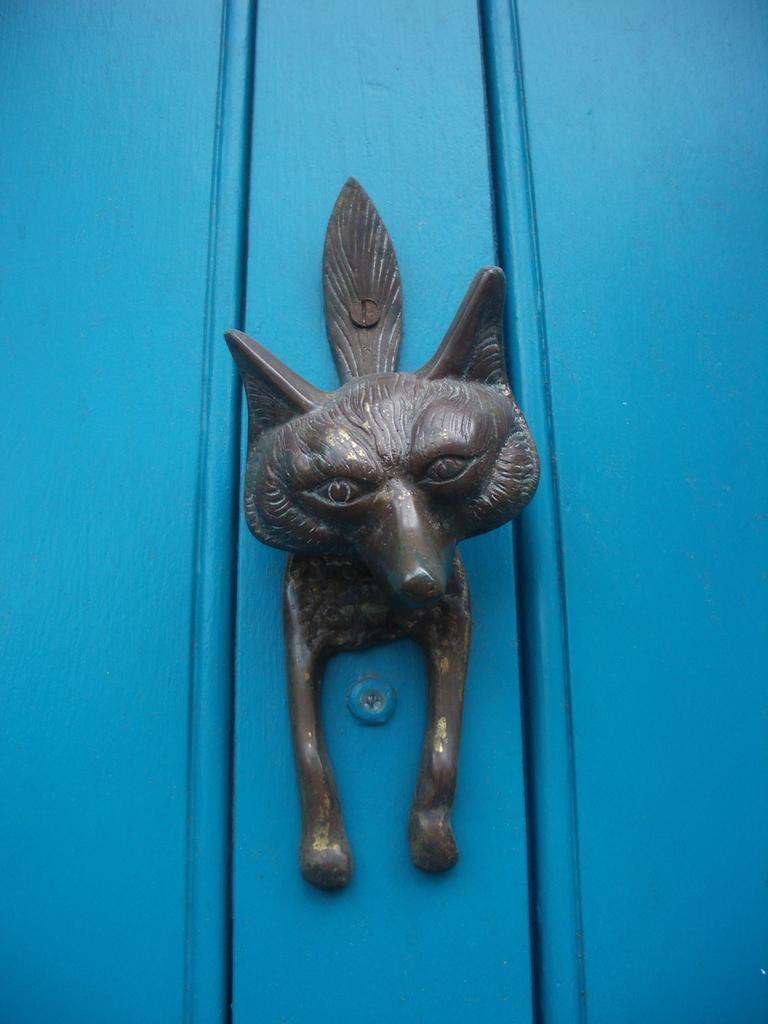Could you give a brief overview of what you see in this image? In this image in the center there is toy, and in the background there is a door. 